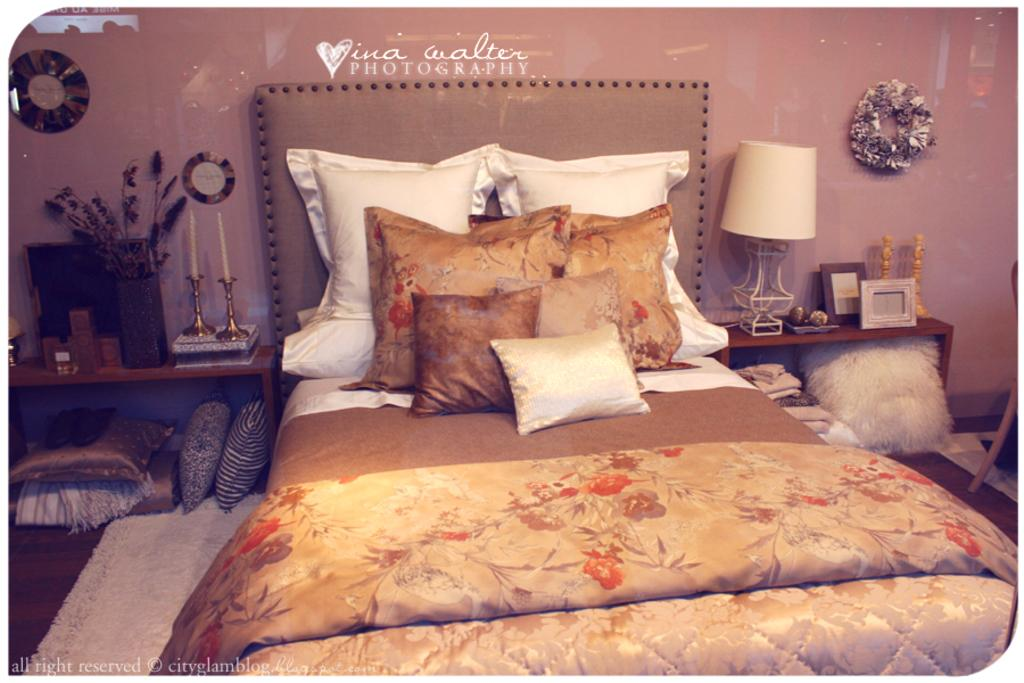What type of furniture is present in the image? There is a bed in the image. What is covering the bed? There is a blanket on the bed. What is used for head support on the bed? There are pillows on the bed. What type of flooring is visible in the image? There is a carpet and tiles in the image. What type of lighting is present in the image? There is a lamp in the image. What type of decorative items are present in the image? There are frames and candles in the image. What type of container is present in the image? There is a vase in the image. What type of objects are present in the image? There are objects in the image. What can be seen in the background of the image? There is a wall and decorative items in the background of the image. How many questions are being asked in the image? There are no questions visible in the image; it is a still image of a room. What type of crack is present in the image? There is no crack present in the image. What type of heat source is visible in the image? There is no heat source visible in the image. 